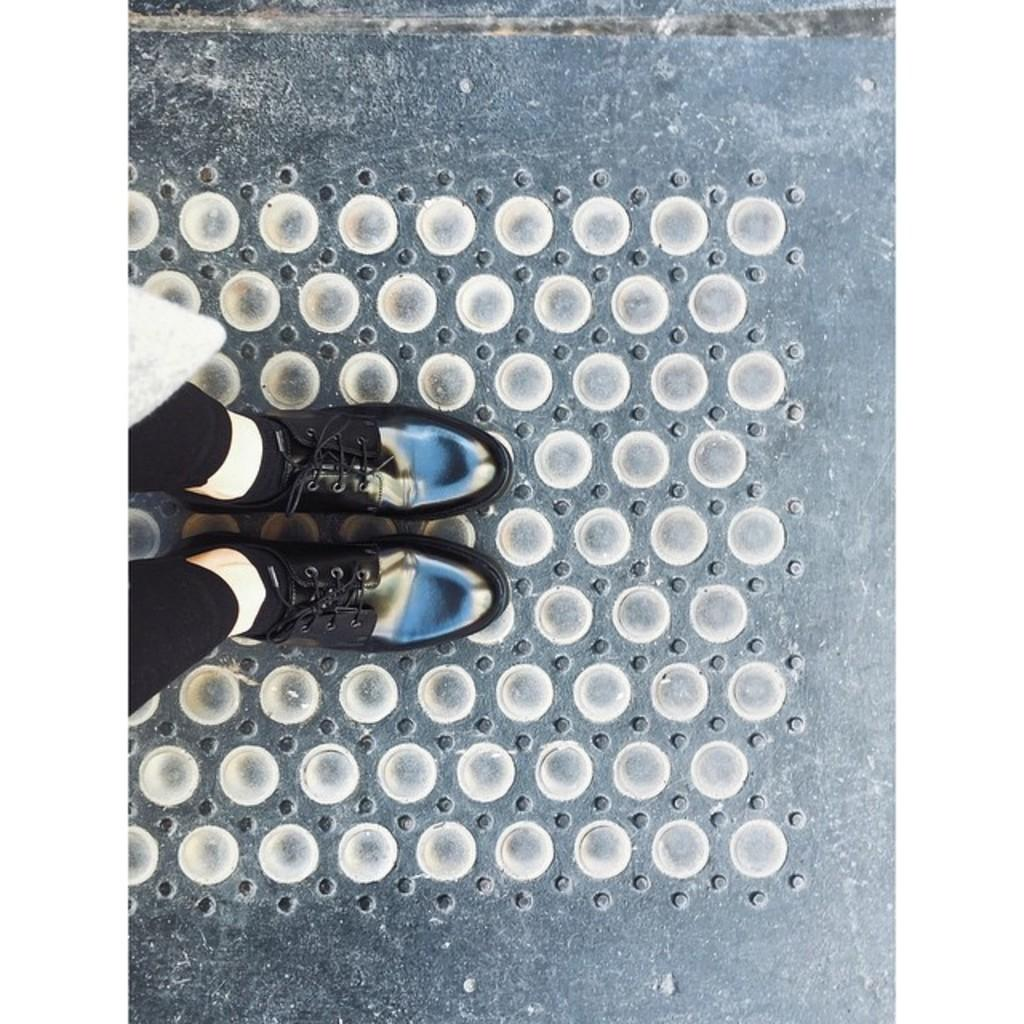What part of a person can be seen in the image? There are legs of a person visible in the image. What color are the pants the person is wearing? The person is wearing black pants. What type of footwear is the person wearing? The person is wearing black shoes. What type of socks is the person wearing? The person is wearing black socks. What can be seen on the ground in the image? There are round things on the ground in the image. What type of camera is the person holding in the image? There is no camera visible in the image; only the person's legs and clothing can be seen. What is the shape of the person's heart in the image? There is no heart visible in the image, as it is a photograph of a person's legs and clothing. 